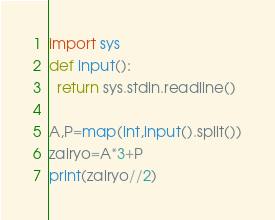<code> <loc_0><loc_0><loc_500><loc_500><_Python_>import sys
def input():
  return sys.stdin.readline()

A,P=map(int,input().split())
zairyo=A*3+P
print(zairyo//2)</code> 